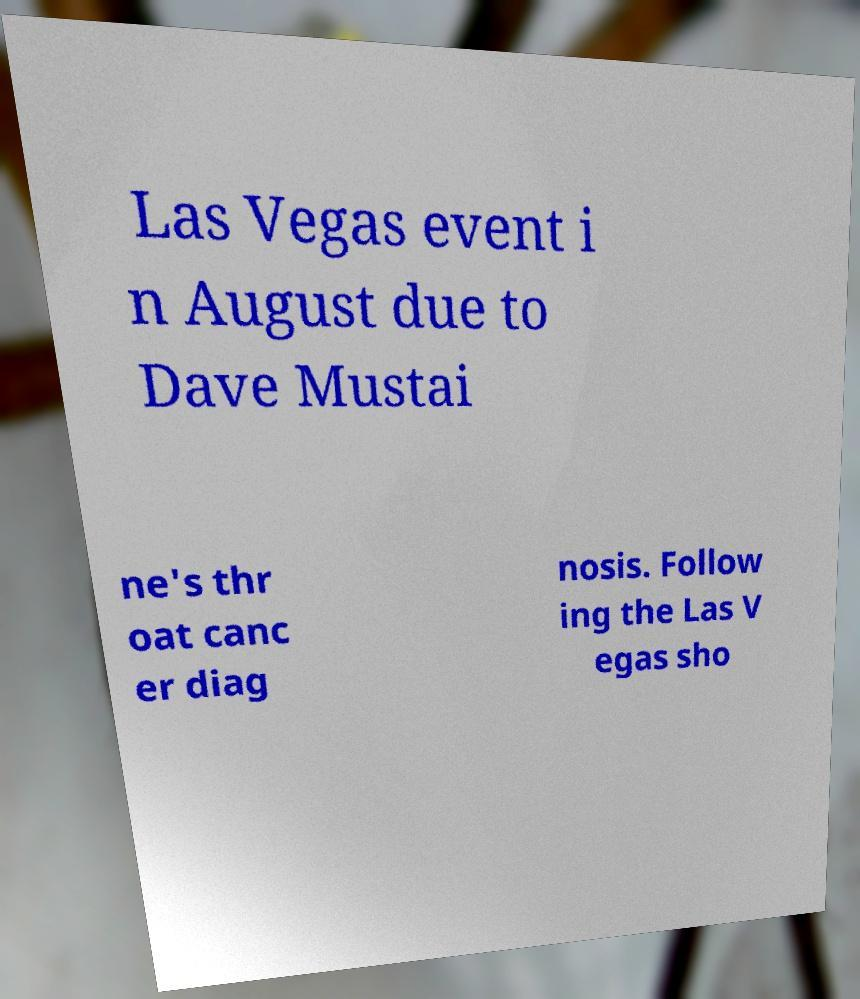Please identify and transcribe the text found in this image. Las Vegas event i n August due to Dave Mustai ne's thr oat canc er diag nosis. Follow ing the Las V egas sho 